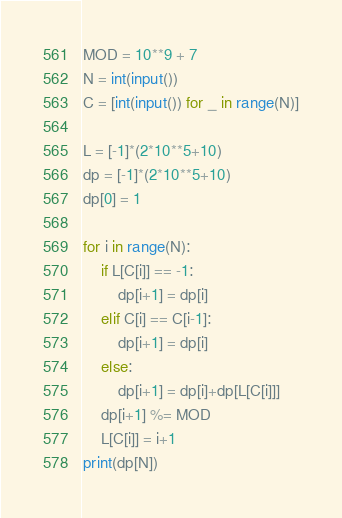Convert code to text. <code><loc_0><loc_0><loc_500><loc_500><_Python_>MOD = 10**9 + 7
N = int(input())
C = [int(input()) for _ in range(N)]

L = [-1]*(2*10**5+10)
dp = [-1]*(2*10**5+10)
dp[0] = 1

for i in range(N):
    if L[C[i]] == -1:
        dp[i+1] = dp[i]
    elif C[i] == C[i-1]:
        dp[i+1] = dp[i]
    else:
        dp[i+1] = dp[i]+dp[L[C[i]]]
    dp[i+1] %= MOD
    L[C[i]] = i+1
print(dp[N])
</code> 